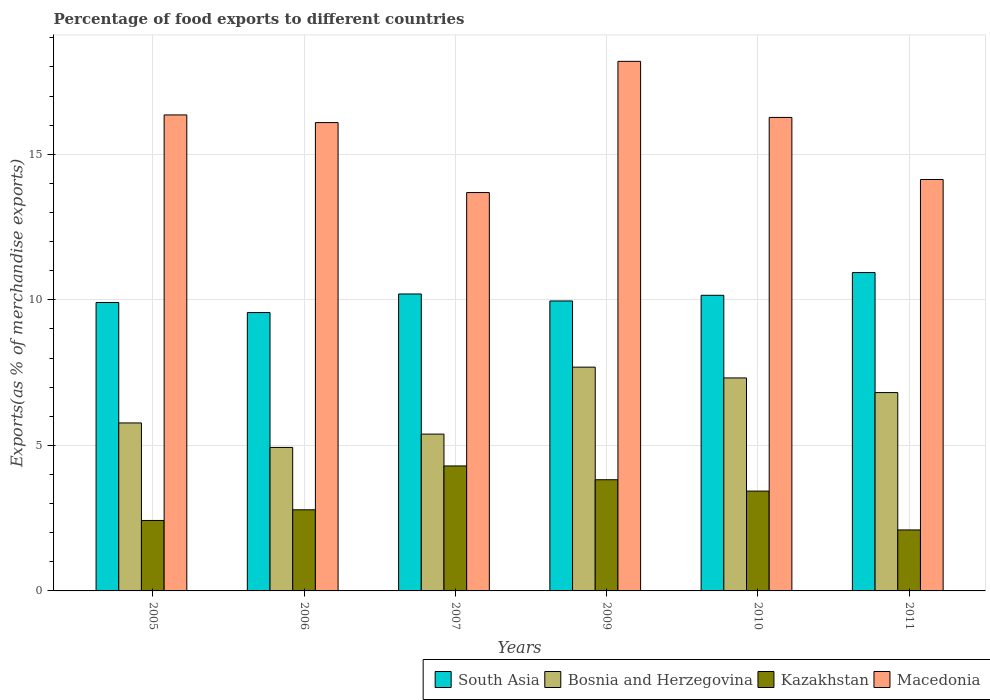How many different coloured bars are there?
Keep it short and to the point. 4. Are the number of bars on each tick of the X-axis equal?
Make the answer very short. Yes. What is the label of the 3rd group of bars from the left?
Provide a short and direct response. 2007. What is the percentage of exports to different countries in South Asia in 2009?
Your answer should be compact. 9.96. Across all years, what is the maximum percentage of exports to different countries in Kazakhstan?
Provide a succinct answer. 4.29. Across all years, what is the minimum percentage of exports to different countries in Bosnia and Herzegovina?
Offer a very short reply. 4.93. In which year was the percentage of exports to different countries in Macedonia maximum?
Your answer should be compact. 2009. In which year was the percentage of exports to different countries in Bosnia and Herzegovina minimum?
Provide a succinct answer. 2006. What is the total percentage of exports to different countries in Kazakhstan in the graph?
Provide a succinct answer. 18.85. What is the difference between the percentage of exports to different countries in South Asia in 2007 and that in 2009?
Ensure brevity in your answer.  0.24. What is the difference between the percentage of exports to different countries in South Asia in 2007 and the percentage of exports to different countries in Kazakhstan in 2011?
Make the answer very short. 8.11. What is the average percentage of exports to different countries in South Asia per year?
Your answer should be very brief. 10.12. In the year 2005, what is the difference between the percentage of exports to different countries in South Asia and percentage of exports to different countries in Bosnia and Herzegovina?
Provide a short and direct response. 4.14. In how many years, is the percentage of exports to different countries in South Asia greater than 11 %?
Give a very brief answer. 0. What is the ratio of the percentage of exports to different countries in Bosnia and Herzegovina in 2007 to that in 2011?
Ensure brevity in your answer.  0.79. Is the difference between the percentage of exports to different countries in South Asia in 2005 and 2010 greater than the difference between the percentage of exports to different countries in Bosnia and Herzegovina in 2005 and 2010?
Your answer should be compact. Yes. What is the difference between the highest and the second highest percentage of exports to different countries in Bosnia and Herzegovina?
Provide a succinct answer. 0.37. What is the difference between the highest and the lowest percentage of exports to different countries in Kazakhstan?
Offer a very short reply. 2.2. Is the sum of the percentage of exports to different countries in Kazakhstan in 2007 and 2011 greater than the maximum percentage of exports to different countries in Macedonia across all years?
Your answer should be compact. No. Is it the case that in every year, the sum of the percentage of exports to different countries in Macedonia and percentage of exports to different countries in Kazakhstan is greater than the sum of percentage of exports to different countries in South Asia and percentage of exports to different countries in Bosnia and Herzegovina?
Provide a succinct answer. Yes. What does the 3rd bar from the left in 2005 represents?
Offer a very short reply. Kazakhstan. What does the 1st bar from the right in 2006 represents?
Your answer should be compact. Macedonia. Is it the case that in every year, the sum of the percentage of exports to different countries in Kazakhstan and percentage of exports to different countries in Bosnia and Herzegovina is greater than the percentage of exports to different countries in South Asia?
Make the answer very short. No. Are all the bars in the graph horizontal?
Offer a very short reply. No. How many years are there in the graph?
Provide a short and direct response. 6. Are the values on the major ticks of Y-axis written in scientific E-notation?
Offer a very short reply. No. Does the graph contain any zero values?
Keep it short and to the point. No. Where does the legend appear in the graph?
Your response must be concise. Bottom right. What is the title of the graph?
Keep it short and to the point. Percentage of food exports to different countries. Does "Nicaragua" appear as one of the legend labels in the graph?
Provide a short and direct response. No. What is the label or title of the X-axis?
Your response must be concise. Years. What is the label or title of the Y-axis?
Offer a very short reply. Exports(as % of merchandise exports). What is the Exports(as % of merchandise exports) of South Asia in 2005?
Offer a very short reply. 9.91. What is the Exports(as % of merchandise exports) of Bosnia and Herzegovina in 2005?
Make the answer very short. 5.77. What is the Exports(as % of merchandise exports) of Kazakhstan in 2005?
Offer a very short reply. 2.42. What is the Exports(as % of merchandise exports) of Macedonia in 2005?
Ensure brevity in your answer.  16.35. What is the Exports(as % of merchandise exports) of South Asia in 2006?
Your response must be concise. 9.56. What is the Exports(as % of merchandise exports) in Bosnia and Herzegovina in 2006?
Provide a short and direct response. 4.93. What is the Exports(as % of merchandise exports) in Kazakhstan in 2006?
Provide a short and direct response. 2.79. What is the Exports(as % of merchandise exports) in Macedonia in 2006?
Provide a short and direct response. 16.09. What is the Exports(as % of merchandise exports) in South Asia in 2007?
Keep it short and to the point. 10.2. What is the Exports(as % of merchandise exports) of Bosnia and Herzegovina in 2007?
Ensure brevity in your answer.  5.39. What is the Exports(as % of merchandise exports) of Kazakhstan in 2007?
Give a very brief answer. 4.29. What is the Exports(as % of merchandise exports) of Macedonia in 2007?
Keep it short and to the point. 13.69. What is the Exports(as % of merchandise exports) in South Asia in 2009?
Your answer should be compact. 9.96. What is the Exports(as % of merchandise exports) of Bosnia and Herzegovina in 2009?
Keep it short and to the point. 7.69. What is the Exports(as % of merchandise exports) in Kazakhstan in 2009?
Offer a terse response. 3.82. What is the Exports(as % of merchandise exports) of Macedonia in 2009?
Give a very brief answer. 18.19. What is the Exports(as % of merchandise exports) in South Asia in 2010?
Offer a very short reply. 10.16. What is the Exports(as % of merchandise exports) in Bosnia and Herzegovina in 2010?
Offer a terse response. 7.32. What is the Exports(as % of merchandise exports) of Kazakhstan in 2010?
Keep it short and to the point. 3.43. What is the Exports(as % of merchandise exports) of Macedonia in 2010?
Offer a very short reply. 16.27. What is the Exports(as % of merchandise exports) of South Asia in 2011?
Ensure brevity in your answer.  10.94. What is the Exports(as % of merchandise exports) of Bosnia and Herzegovina in 2011?
Offer a terse response. 6.81. What is the Exports(as % of merchandise exports) in Kazakhstan in 2011?
Your answer should be very brief. 2.1. What is the Exports(as % of merchandise exports) of Macedonia in 2011?
Your answer should be very brief. 14.13. Across all years, what is the maximum Exports(as % of merchandise exports) in South Asia?
Provide a succinct answer. 10.94. Across all years, what is the maximum Exports(as % of merchandise exports) in Bosnia and Herzegovina?
Make the answer very short. 7.69. Across all years, what is the maximum Exports(as % of merchandise exports) in Kazakhstan?
Offer a very short reply. 4.29. Across all years, what is the maximum Exports(as % of merchandise exports) of Macedonia?
Your response must be concise. 18.19. Across all years, what is the minimum Exports(as % of merchandise exports) in South Asia?
Make the answer very short. 9.56. Across all years, what is the minimum Exports(as % of merchandise exports) in Bosnia and Herzegovina?
Offer a terse response. 4.93. Across all years, what is the minimum Exports(as % of merchandise exports) of Kazakhstan?
Offer a very short reply. 2.1. Across all years, what is the minimum Exports(as % of merchandise exports) of Macedonia?
Ensure brevity in your answer.  13.69. What is the total Exports(as % of merchandise exports) of South Asia in the graph?
Ensure brevity in your answer.  60.73. What is the total Exports(as % of merchandise exports) of Bosnia and Herzegovina in the graph?
Offer a very short reply. 37.91. What is the total Exports(as % of merchandise exports) in Kazakhstan in the graph?
Offer a terse response. 18.85. What is the total Exports(as % of merchandise exports) in Macedonia in the graph?
Your answer should be very brief. 94.72. What is the difference between the Exports(as % of merchandise exports) in South Asia in 2005 and that in 2006?
Keep it short and to the point. 0.34. What is the difference between the Exports(as % of merchandise exports) of Bosnia and Herzegovina in 2005 and that in 2006?
Your response must be concise. 0.84. What is the difference between the Exports(as % of merchandise exports) of Kazakhstan in 2005 and that in 2006?
Your answer should be very brief. -0.37. What is the difference between the Exports(as % of merchandise exports) of Macedonia in 2005 and that in 2006?
Your answer should be very brief. 0.26. What is the difference between the Exports(as % of merchandise exports) in South Asia in 2005 and that in 2007?
Keep it short and to the point. -0.29. What is the difference between the Exports(as % of merchandise exports) in Bosnia and Herzegovina in 2005 and that in 2007?
Keep it short and to the point. 0.38. What is the difference between the Exports(as % of merchandise exports) in Kazakhstan in 2005 and that in 2007?
Offer a very short reply. -1.87. What is the difference between the Exports(as % of merchandise exports) in Macedonia in 2005 and that in 2007?
Provide a short and direct response. 2.67. What is the difference between the Exports(as % of merchandise exports) in South Asia in 2005 and that in 2009?
Offer a very short reply. -0.05. What is the difference between the Exports(as % of merchandise exports) of Bosnia and Herzegovina in 2005 and that in 2009?
Make the answer very short. -1.92. What is the difference between the Exports(as % of merchandise exports) of Kazakhstan in 2005 and that in 2009?
Your answer should be very brief. -1.4. What is the difference between the Exports(as % of merchandise exports) in Macedonia in 2005 and that in 2009?
Give a very brief answer. -1.84. What is the difference between the Exports(as % of merchandise exports) of South Asia in 2005 and that in 2010?
Provide a short and direct response. -0.25. What is the difference between the Exports(as % of merchandise exports) in Bosnia and Herzegovina in 2005 and that in 2010?
Provide a short and direct response. -1.55. What is the difference between the Exports(as % of merchandise exports) of Kazakhstan in 2005 and that in 2010?
Offer a terse response. -1.01. What is the difference between the Exports(as % of merchandise exports) in Macedonia in 2005 and that in 2010?
Your answer should be compact. 0.09. What is the difference between the Exports(as % of merchandise exports) in South Asia in 2005 and that in 2011?
Keep it short and to the point. -1.03. What is the difference between the Exports(as % of merchandise exports) of Bosnia and Herzegovina in 2005 and that in 2011?
Give a very brief answer. -1.04. What is the difference between the Exports(as % of merchandise exports) in Kazakhstan in 2005 and that in 2011?
Your answer should be very brief. 0.33. What is the difference between the Exports(as % of merchandise exports) in Macedonia in 2005 and that in 2011?
Keep it short and to the point. 2.22. What is the difference between the Exports(as % of merchandise exports) of South Asia in 2006 and that in 2007?
Your answer should be compact. -0.64. What is the difference between the Exports(as % of merchandise exports) of Bosnia and Herzegovina in 2006 and that in 2007?
Make the answer very short. -0.46. What is the difference between the Exports(as % of merchandise exports) in Kazakhstan in 2006 and that in 2007?
Ensure brevity in your answer.  -1.51. What is the difference between the Exports(as % of merchandise exports) of Macedonia in 2006 and that in 2007?
Give a very brief answer. 2.4. What is the difference between the Exports(as % of merchandise exports) of South Asia in 2006 and that in 2009?
Your answer should be very brief. -0.4. What is the difference between the Exports(as % of merchandise exports) of Bosnia and Herzegovina in 2006 and that in 2009?
Provide a short and direct response. -2.76. What is the difference between the Exports(as % of merchandise exports) of Kazakhstan in 2006 and that in 2009?
Your answer should be compact. -1.03. What is the difference between the Exports(as % of merchandise exports) of Macedonia in 2006 and that in 2009?
Your answer should be compact. -2.1. What is the difference between the Exports(as % of merchandise exports) in South Asia in 2006 and that in 2010?
Provide a succinct answer. -0.59. What is the difference between the Exports(as % of merchandise exports) in Bosnia and Herzegovina in 2006 and that in 2010?
Offer a terse response. -2.39. What is the difference between the Exports(as % of merchandise exports) of Kazakhstan in 2006 and that in 2010?
Offer a terse response. -0.64. What is the difference between the Exports(as % of merchandise exports) in Macedonia in 2006 and that in 2010?
Provide a succinct answer. -0.18. What is the difference between the Exports(as % of merchandise exports) in South Asia in 2006 and that in 2011?
Provide a succinct answer. -1.37. What is the difference between the Exports(as % of merchandise exports) of Bosnia and Herzegovina in 2006 and that in 2011?
Provide a short and direct response. -1.88. What is the difference between the Exports(as % of merchandise exports) of Kazakhstan in 2006 and that in 2011?
Offer a terse response. 0.69. What is the difference between the Exports(as % of merchandise exports) in Macedonia in 2006 and that in 2011?
Ensure brevity in your answer.  1.96. What is the difference between the Exports(as % of merchandise exports) in South Asia in 2007 and that in 2009?
Provide a short and direct response. 0.24. What is the difference between the Exports(as % of merchandise exports) of Bosnia and Herzegovina in 2007 and that in 2009?
Offer a very short reply. -2.3. What is the difference between the Exports(as % of merchandise exports) in Kazakhstan in 2007 and that in 2009?
Offer a very short reply. 0.47. What is the difference between the Exports(as % of merchandise exports) in Macedonia in 2007 and that in 2009?
Give a very brief answer. -4.51. What is the difference between the Exports(as % of merchandise exports) in South Asia in 2007 and that in 2010?
Your answer should be very brief. 0.05. What is the difference between the Exports(as % of merchandise exports) of Bosnia and Herzegovina in 2007 and that in 2010?
Give a very brief answer. -1.93. What is the difference between the Exports(as % of merchandise exports) of Kazakhstan in 2007 and that in 2010?
Ensure brevity in your answer.  0.86. What is the difference between the Exports(as % of merchandise exports) of Macedonia in 2007 and that in 2010?
Give a very brief answer. -2.58. What is the difference between the Exports(as % of merchandise exports) of South Asia in 2007 and that in 2011?
Offer a very short reply. -0.74. What is the difference between the Exports(as % of merchandise exports) of Bosnia and Herzegovina in 2007 and that in 2011?
Provide a succinct answer. -1.43. What is the difference between the Exports(as % of merchandise exports) of Kazakhstan in 2007 and that in 2011?
Keep it short and to the point. 2.2. What is the difference between the Exports(as % of merchandise exports) of Macedonia in 2007 and that in 2011?
Provide a short and direct response. -0.45. What is the difference between the Exports(as % of merchandise exports) of South Asia in 2009 and that in 2010?
Make the answer very short. -0.19. What is the difference between the Exports(as % of merchandise exports) of Bosnia and Herzegovina in 2009 and that in 2010?
Give a very brief answer. 0.37. What is the difference between the Exports(as % of merchandise exports) of Kazakhstan in 2009 and that in 2010?
Make the answer very short. 0.39. What is the difference between the Exports(as % of merchandise exports) in Macedonia in 2009 and that in 2010?
Keep it short and to the point. 1.93. What is the difference between the Exports(as % of merchandise exports) in South Asia in 2009 and that in 2011?
Your response must be concise. -0.98. What is the difference between the Exports(as % of merchandise exports) of Bosnia and Herzegovina in 2009 and that in 2011?
Give a very brief answer. 0.87. What is the difference between the Exports(as % of merchandise exports) in Kazakhstan in 2009 and that in 2011?
Your response must be concise. 1.72. What is the difference between the Exports(as % of merchandise exports) of Macedonia in 2009 and that in 2011?
Provide a succinct answer. 4.06. What is the difference between the Exports(as % of merchandise exports) of South Asia in 2010 and that in 2011?
Provide a short and direct response. -0.78. What is the difference between the Exports(as % of merchandise exports) in Bosnia and Herzegovina in 2010 and that in 2011?
Your response must be concise. 0.5. What is the difference between the Exports(as % of merchandise exports) in Kazakhstan in 2010 and that in 2011?
Offer a very short reply. 1.33. What is the difference between the Exports(as % of merchandise exports) of Macedonia in 2010 and that in 2011?
Ensure brevity in your answer.  2.13. What is the difference between the Exports(as % of merchandise exports) of South Asia in 2005 and the Exports(as % of merchandise exports) of Bosnia and Herzegovina in 2006?
Keep it short and to the point. 4.98. What is the difference between the Exports(as % of merchandise exports) of South Asia in 2005 and the Exports(as % of merchandise exports) of Kazakhstan in 2006?
Keep it short and to the point. 7.12. What is the difference between the Exports(as % of merchandise exports) of South Asia in 2005 and the Exports(as % of merchandise exports) of Macedonia in 2006?
Provide a short and direct response. -6.18. What is the difference between the Exports(as % of merchandise exports) of Bosnia and Herzegovina in 2005 and the Exports(as % of merchandise exports) of Kazakhstan in 2006?
Keep it short and to the point. 2.98. What is the difference between the Exports(as % of merchandise exports) in Bosnia and Herzegovina in 2005 and the Exports(as % of merchandise exports) in Macedonia in 2006?
Your answer should be compact. -10.32. What is the difference between the Exports(as % of merchandise exports) in Kazakhstan in 2005 and the Exports(as % of merchandise exports) in Macedonia in 2006?
Offer a terse response. -13.67. What is the difference between the Exports(as % of merchandise exports) in South Asia in 2005 and the Exports(as % of merchandise exports) in Bosnia and Herzegovina in 2007?
Offer a very short reply. 4.52. What is the difference between the Exports(as % of merchandise exports) of South Asia in 2005 and the Exports(as % of merchandise exports) of Kazakhstan in 2007?
Your response must be concise. 5.61. What is the difference between the Exports(as % of merchandise exports) in South Asia in 2005 and the Exports(as % of merchandise exports) in Macedonia in 2007?
Offer a terse response. -3.78. What is the difference between the Exports(as % of merchandise exports) of Bosnia and Herzegovina in 2005 and the Exports(as % of merchandise exports) of Kazakhstan in 2007?
Your answer should be compact. 1.48. What is the difference between the Exports(as % of merchandise exports) of Bosnia and Herzegovina in 2005 and the Exports(as % of merchandise exports) of Macedonia in 2007?
Provide a short and direct response. -7.92. What is the difference between the Exports(as % of merchandise exports) in Kazakhstan in 2005 and the Exports(as % of merchandise exports) in Macedonia in 2007?
Give a very brief answer. -11.27. What is the difference between the Exports(as % of merchandise exports) of South Asia in 2005 and the Exports(as % of merchandise exports) of Bosnia and Herzegovina in 2009?
Your answer should be compact. 2.22. What is the difference between the Exports(as % of merchandise exports) in South Asia in 2005 and the Exports(as % of merchandise exports) in Kazakhstan in 2009?
Offer a terse response. 6.09. What is the difference between the Exports(as % of merchandise exports) of South Asia in 2005 and the Exports(as % of merchandise exports) of Macedonia in 2009?
Your response must be concise. -8.28. What is the difference between the Exports(as % of merchandise exports) in Bosnia and Herzegovina in 2005 and the Exports(as % of merchandise exports) in Kazakhstan in 2009?
Ensure brevity in your answer.  1.95. What is the difference between the Exports(as % of merchandise exports) of Bosnia and Herzegovina in 2005 and the Exports(as % of merchandise exports) of Macedonia in 2009?
Your answer should be compact. -12.42. What is the difference between the Exports(as % of merchandise exports) in Kazakhstan in 2005 and the Exports(as % of merchandise exports) in Macedonia in 2009?
Your answer should be compact. -15.77. What is the difference between the Exports(as % of merchandise exports) of South Asia in 2005 and the Exports(as % of merchandise exports) of Bosnia and Herzegovina in 2010?
Your answer should be compact. 2.59. What is the difference between the Exports(as % of merchandise exports) in South Asia in 2005 and the Exports(as % of merchandise exports) in Kazakhstan in 2010?
Provide a short and direct response. 6.48. What is the difference between the Exports(as % of merchandise exports) in South Asia in 2005 and the Exports(as % of merchandise exports) in Macedonia in 2010?
Your answer should be very brief. -6.36. What is the difference between the Exports(as % of merchandise exports) in Bosnia and Herzegovina in 2005 and the Exports(as % of merchandise exports) in Kazakhstan in 2010?
Give a very brief answer. 2.34. What is the difference between the Exports(as % of merchandise exports) of Bosnia and Herzegovina in 2005 and the Exports(as % of merchandise exports) of Macedonia in 2010?
Ensure brevity in your answer.  -10.5. What is the difference between the Exports(as % of merchandise exports) of Kazakhstan in 2005 and the Exports(as % of merchandise exports) of Macedonia in 2010?
Provide a succinct answer. -13.85. What is the difference between the Exports(as % of merchandise exports) in South Asia in 2005 and the Exports(as % of merchandise exports) in Bosnia and Herzegovina in 2011?
Provide a short and direct response. 3.09. What is the difference between the Exports(as % of merchandise exports) of South Asia in 2005 and the Exports(as % of merchandise exports) of Kazakhstan in 2011?
Your response must be concise. 7.81. What is the difference between the Exports(as % of merchandise exports) of South Asia in 2005 and the Exports(as % of merchandise exports) of Macedonia in 2011?
Your answer should be very brief. -4.23. What is the difference between the Exports(as % of merchandise exports) in Bosnia and Herzegovina in 2005 and the Exports(as % of merchandise exports) in Kazakhstan in 2011?
Give a very brief answer. 3.68. What is the difference between the Exports(as % of merchandise exports) in Bosnia and Herzegovina in 2005 and the Exports(as % of merchandise exports) in Macedonia in 2011?
Offer a terse response. -8.36. What is the difference between the Exports(as % of merchandise exports) in Kazakhstan in 2005 and the Exports(as % of merchandise exports) in Macedonia in 2011?
Make the answer very short. -11.71. What is the difference between the Exports(as % of merchandise exports) in South Asia in 2006 and the Exports(as % of merchandise exports) in Bosnia and Herzegovina in 2007?
Your response must be concise. 4.18. What is the difference between the Exports(as % of merchandise exports) in South Asia in 2006 and the Exports(as % of merchandise exports) in Kazakhstan in 2007?
Provide a succinct answer. 5.27. What is the difference between the Exports(as % of merchandise exports) of South Asia in 2006 and the Exports(as % of merchandise exports) of Macedonia in 2007?
Your response must be concise. -4.12. What is the difference between the Exports(as % of merchandise exports) in Bosnia and Herzegovina in 2006 and the Exports(as % of merchandise exports) in Kazakhstan in 2007?
Provide a short and direct response. 0.64. What is the difference between the Exports(as % of merchandise exports) in Bosnia and Herzegovina in 2006 and the Exports(as % of merchandise exports) in Macedonia in 2007?
Your answer should be compact. -8.76. What is the difference between the Exports(as % of merchandise exports) in Kazakhstan in 2006 and the Exports(as % of merchandise exports) in Macedonia in 2007?
Ensure brevity in your answer.  -10.9. What is the difference between the Exports(as % of merchandise exports) in South Asia in 2006 and the Exports(as % of merchandise exports) in Bosnia and Herzegovina in 2009?
Provide a succinct answer. 1.88. What is the difference between the Exports(as % of merchandise exports) of South Asia in 2006 and the Exports(as % of merchandise exports) of Kazakhstan in 2009?
Provide a succinct answer. 5.74. What is the difference between the Exports(as % of merchandise exports) of South Asia in 2006 and the Exports(as % of merchandise exports) of Macedonia in 2009?
Your answer should be compact. -8.63. What is the difference between the Exports(as % of merchandise exports) in Bosnia and Herzegovina in 2006 and the Exports(as % of merchandise exports) in Kazakhstan in 2009?
Offer a terse response. 1.11. What is the difference between the Exports(as % of merchandise exports) in Bosnia and Herzegovina in 2006 and the Exports(as % of merchandise exports) in Macedonia in 2009?
Keep it short and to the point. -13.26. What is the difference between the Exports(as % of merchandise exports) of Kazakhstan in 2006 and the Exports(as % of merchandise exports) of Macedonia in 2009?
Provide a short and direct response. -15.41. What is the difference between the Exports(as % of merchandise exports) in South Asia in 2006 and the Exports(as % of merchandise exports) in Bosnia and Herzegovina in 2010?
Provide a short and direct response. 2.25. What is the difference between the Exports(as % of merchandise exports) of South Asia in 2006 and the Exports(as % of merchandise exports) of Kazakhstan in 2010?
Give a very brief answer. 6.13. What is the difference between the Exports(as % of merchandise exports) in South Asia in 2006 and the Exports(as % of merchandise exports) in Macedonia in 2010?
Provide a short and direct response. -6.7. What is the difference between the Exports(as % of merchandise exports) in Bosnia and Herzegovina in 2006 and the Exports(as % of merchandise exports) in Kazakhstan in 2010?
Give a very brief answer. 1.5. What is the difference between the Exports(as % of merchandise exports) of Bosnia and Herzegovina in 2006 and the Exports(as % of merchandise exports) of Macedonia in 2010?
Give a very brief answer. -11.34. What is the difference between the Exports(as % of merchandise exports) of Kazakhstan in 2006 and the Exports(as % of merchandise exports) of Macedonia in 2010?
Provide a short and direct response. -13.48. What is the difference between the Exports(as % of merchandise exports) of South Asia in 2006 and the Exports(as % of merchandise exports) of Bosnia and Herzegovina in 2011?
Offer a very short reply. 2.75. What is the difference between the Exports(as % of merchandise exports) in South Asia in 2006 and the Exports(as % of merchandise exports) in Kazakhstan in 2011?
Provide a short and direct response. 7.47. What is the difference between the Exports(as % of merchandise exports) of South Asia in 2006 and the Exports(as % of merchandise exports) of Macedonia in 2011?
Give a very brief answer. -4.57. What is the difference between the Exports(as % of merchandise exports) in Bosnia and Herzegovina in 2006 and the Exports(as % of merchandise exports) in Kazakhstan in 2011?
Your response must be concise. 2.83. What is the difference between the Exports(as % of merchandise exports) of Bosnia and Herzegovina in 2006 and the Exports(as % of merchandise exports) of Macedonia in 2011?
Provide a succinct answer. -9.2. What is the difference between the Exports(as % of merchandise exports) of Kazakhstan in 2006 and the Exports(as % of merchandise exports) of Macedonia in 2011?
Offer a very short reply. -11.35. What is the difference between the Exports(as % of merchandise exports) in South Asia in 2007 and the Exports(as % of merchandise exports) in Bosnia and Herzegovina in 2009?
Your answer should be very brief. 2.51. What is the difference between the Exports(as % of merchandise exports) of South Asia in 2007 and the Exports(as % of merchandise exports) of Kazakhstan in 2009?
Give a very brief answer. 6.38. What is the difference between the Exports(as % of merchandise exports) of South Asia in 2007 and the Exports(as % of merchandise exports) of Macedonia in 2009?
Your answer should be compact. -7.99. What is the difference between the Exports(as % of merchandise exports) in Bosnia and Herzegovina in 2007 and the Exports(as % of merchandise exports) in Kazakhstan in 2009?
Your response must be concise. 1.57. What is the difference between the Exports(as % of merchandise exports) in Bosnia and Herzegovina in 2007 and the Exports(as % of merchandise exports) in Macedonia in 2009?
Provide a succinct answer. -12.81. What is the difference between the Exports(as % of merchandise exports) in Kazakhstan in 2007 and the Exports(as % of merchandise exports) in Macedonia in 2009?
Your answer should be compact. -13.9. What is the difference between the Exports(as % of merchandise exports) in South Asia in 2007 and the Exports(as % of merchandise exports) in Bosnia and Herzegovina in 2010?
Your response must be concise. 2.88. What is the difference between the Exports(as % of merchandise exports) in South Asia in 2007 and the Exports(as % of merchandise exports) in Kazakhstan in 2010?
Give a very brief answer. 6.77. What is the difference between the Exports(as % of merchandise exports) in South Asia in 2007 and the Exports(as % of merchandise exports) in Macedonia in 2010?
Provide a short and direct response. -6.07. What is the difference between the Exports(as % of merchandise exports) of Bosnia and Herzegovina in 2007 and the Exports(as % of merchandise exports) of Kazakhstan in 2010?
Keep it short and to the point. 1.96. What is the difference between the Exports(as % of merchandise exports) of Bosnia and Herzegovina in 2007 and the Exports(as % of merchandise exports) of Macedonia in 2010?
Ensure brevity in your answer.  -10.88. What is the difference between the Exports(as % of merchandise exports) of Kazakhstan in 2007 and the Exports(as % of merchandise exports) of Macedonia in 2010?
Offer a very short reply. -11.97. What is the difference between the Exports(as % of merchandise exports) in South Asia in 2007 and the Exports(as % of merchandise exports) in Bosnia and Herzegovina in 2011?
Provide a succinct answer. 3.39. What is the difference between the Exports(as % of merchandise exports) of South Asia in 2007 and the Exports(as % of merchandise exports) of Kazakhstan in 2011?
Provide a short and direct response. 8.11. What is the difference between the Exports(as % of merchandise exports) in South Asia in 2007 and the Exports(as % of merchandise exports) in Macedonia in 2011?
Provide a short and direct response. -3.93. What is the difference between the Exports(as % of merchandise exports) in Bosnia and Herzegovina in 2007 and the Exports(as % of merchandise exports) in Kazakhstan in 2011?
Provide a short and direct response. 3.29. What is the difference between the Exports(as % of merchandise exports) of Bosnia and Herzegovina in 2007 and the Exports(as % of merchandise exports) of Macedonia in 2011?
Your answer should be compact. -8.75. What is the difference between the Exports(as % of merchandise exports) of Kazakhstan in 2007 and the Exports(as % of merchandise exports) of Macedonia in 2011?
Offer a very short reply. -9.84. What is the difference between the Exports(as % of merchandise exports) of South Asia in 2009 and the Exports(as % of merchandise exports) of Bosnia and Herzegovina in 2010?
Your response must be concise. 2.64. What is the difference between the Exports(as % of merchandise exports) of South Asia in 2009 and the Exports(as % of merchandise exports) of Kazakhstan in 2010?
Offer a very short reply. 6.53. What is the difference between the Exports(as % of merchandise exports) of South Asia in 2009 and the Exports(as % of merchandise exports) of Macedonia in 2010?
Offer a terse response. -6.31. What is the difference between the Exports(as % of merchandise exports) of Bosnia and Herzegovina in 2009 and the Exports(as % of merchandise exports) of Kazakhstan in 2010?
Provide a short and direct response. 4.26. What is the difference between the Exports(as % of merchandise exports) of Bosnia and Herzegovina in 2009 and the Exports(as % of merchandise exports) of Macedonia in 2010?
Provide a short and direct response. -8.58. What is the difference between the Exports(as % of merchandise exports) of Kazakhstan in 2009 and the Exports(as % of merchandise exports) of Macedonia in 2010?
Give a very brief answer. -12.45. What is the difference between the Exports(as % of merchandise exports) in South Asia in 2009 and the Exports(as % of merchandise exports) in Bosnia and Herzegovina in 2011?
Offer a terse response. 3.15. What is the difference between the Exports(as % of merchandise exports) of South Asia in 2009 and the Exports(as % of merchandise exports) of Kazakhstan in 2011?
Offer a terse response. 7.87. What is the difference between the Exports(as % of merchandise exports) of South Asia in 2009 and the Exports(as % of merchandise exports) of Macedonia in 2011?
Offer a very short reply. -4.17. What is the difference between the Exports(as % of merchandise exports) of Bosnia and Herzegovina in 2009 and the Exports(as % of merchandise exports) of Kazakhstan in 2011?
Ensure brevity in your answer.  5.59. What is the difference between the Exports(as % of merchandise exports) in Bosnia and Herzegovina in 2009 and the Exports(as % of merchandise exports) in Macedonia in 2011?
Ensure brevity in your answer.  -6.45. What is the difference between the Exports(as % of merchandise exports) in Kazakhstan in 2009 and the Exports(as % of merchandise exports) in Macedonia in 2011?
Your response must be concise. -10.31. What is the difference between the Exports(as % of merchandise exports) of South Asia in 2010 and the Exports(as % of merchandise exports) of Bosnia and Herzegovina in 2011?
Make the answer very short. 3.34. What is the difference between the Exports(as % of merchandise exports) of South Asia in 2010 and the Exports(as % of merchandise exports) of Kazakhstan in 2011?
Offer a very short reply. 8.06. What is the difference between the Exports(as % of merchandise exports) of South Asia in 2010 and the Exports(as % of merchandise exports) of Macedonia in 2011?
Provide a short and direct response. -3.98. What is the difference between the Exports(as % of merchandise exports) of Bosnia and Herzegovina in 2010 and the Exports(as % of merchandise exports) of Kazakhstan in 2011?
Give a very brief answer. 5.22. What is the difference between the Exports(as % of merchandise exports) in Bosnia and Herzegovina in 2010 and the Exports(as % of merchandise exports) in Macedonia in 2011?
Keep it short and to the point. -6.82. What is the difference between the Exports(as % of merchandise exports) of Kazakhstan in 2010 and the Exports(as % of merchandise exports) of Macedonia in 2011?
Give a very brief answer. -10.7. What is the average Exports(as % of merchandise exports) of South Asia per year?
Your answer should be very brief. 10.12. What is the average Exports(as % of merchandise exports) of Bosnia and Herzegovina per year?
Your response must be concise. 6.32. What is the average Exports(as % of merchandise exports) in Kazakhstan per year?
Offer a very short reply. 3.14. What is the average Exports(as % of merchandise exports) of Macedonia per year?
Make the answer very short. 15.79. In the year 2005, what is the difference between the Exports(as % of merchandise exports) in South Asia and Exports(as % of merchandise exports) in Bosnia and Herzegovina?
Your answer should be very brief. 4.14. In the year 2005, what is the difference between the Exports(as % of merchandise exports) in South Asia and Exports(as % of merchandise exports) in Kazakhstan?
Keep it short and to the point. 7.49. In the year 2005, what is the difference between the Exports(as % of merchandise exports) of South Asia and Exports(as % of merchandise exports) of Macedonia?
Make the answer very short. -6.44. In the year 2005, what is the difference between the Exports(as % of merchandise exports) of Bosnia and Herzegovina and Exports(as % of merchandise exports) of Kazakhstan?
Make the answer very short. 3.35. In the year 2005, what is the difference between the Exports(as % of merchandise exports) of Bosnia and Herzegovina and Exports(as % of merchandise exports) of Macedonia?
Ensure brevity in your answer.  -10.58. In the year 2005, what is the difference between the Exports(as % of merchandise exports) of Kazakhstan and Exports(as % of merchandise exports) of Macedonia?
Ensure brevity in your answer.  -13.93. In the year 2006, what is the difference between the Exports(as % of merchandise exports) in South Asia and Exports(as % of merchandise exports) in Bosnia and Herzegovina?
Your response must be concise. 4.63. In the year 2006, what is the difference between the Exports(as % of merchandise exports) in South Asia and Exports(as % of merchandise exports) in Kazakhstan?
Offer a terse response. 6.78. In the year 2006, what is the difference between the Exports(as % of merchandise exports) in South Asia and Exports(as % of merchandise exports) in Macedonia?
Ensure brevity in your answer.  -6.53. In the year 2006, what is the difference between the Exports(as % of merchandise exports) of Bosnia and Herzegovina and Exports(as % of merchandise exports) of Kazakhstan?
Make the answer very short. 2.14. In the year 2006, what is the difference between the Exports(as % of merchandise exports) in Bosnia and Herzegovina and Exports(as % of merchandise exports) in Macedonia?
Provide a short and direct response. -11.16. In the year 2006, what is the difference between the Exports(as % of merchandise exports) of Kazakhstan and Exports(as % of merchandise exports) of Macedonia?
Your answer should be very brief. -13.3. In the year 2007, what is the difference between the Exports(as % of merchandise exports) in South Asia and Exports(as % of merchandise exports) in Bosnia and Herzegovina?
Provide a succinct answer. 4.81. In the year 2007, what is the difference between the Exports(as % of merchandise exports) in South Asia and Exports(as % of merchandise exports) in Kazakhstan?
Keep it short and to the point. 5.91. In the year 2007, what is the difference between the Exports(as % of merchandise exports) in South Asia and Exports(as % of merchandise exports) in Macedonia?
Keep it short and to the point. -3.48. In the year 2007, what is the difference between the Exports(as % of merchandise exports) of Bosnia and Herzegovina and Exports(as % of merchandise exports) of Kazakhstan?
Offer a very short reply. 1.09. In the year 2007, what is the difference between the Exports(as % of merchandise exports) in Bosnia and Herzegovina and Exports(as % of merchandise exports) in Macedonia?
Your answer should be very brief. -8.3. In the year 2007, what is the difference between the Exports(as % of merchandise exports) in Kazakhstan and Exports(as % of merchandise exports) in Macedonia?
Keep it short and to the point. -9.39. In the year 2009, what is the difference between the Exports(as % of merchandise exports) in South Asia and Exports(as % of merchandise exports) in Bosnia and Herzegovina?
Provide a short and direct response. 2.27. In the year 2009, what is the difference between the Exports(as % of merchandise exports) in South Asia and Exports(as % of merchandise exports) in Kazakhstan?
Give a very brief answer. 6.14. In the year 2009, what is the difference between the Exports(as % of merchandise exports) of South Asia and Exports(as % of merchandise exports) of Macedonia?
Offer a terse response. -8.23. In the year 2009, what is the difference between the Exports(as % of merchandise exports) of Bosnia and Herzegovina and Exports(as % of merchandise exports) of Kazakhstan?
Provide a succinct answer. 3.87. In the year 2009, what is the difference between the Exports(as % of merchandise exports) in Bosnia and Herzegovina and Exports(as % of merchandise exports) in Macedonia?
Provide a short and direct response. -10.51. In the year 2009, what is the difference between the Exports(as % of merchandise exports) of Kazakhstan and Exports(as % of merchandise exports) of Macedonia?
Your answer should be very brief. -14.37. In the year 2010, what is the difference between the Exports(as % of merchandise exports) of South Asia and Exports(as % of merchandise exports) of Bosnia and Herzegovina?
Offer a very short reply. 2.84. In the year 2010, what is the difference between the Exports(as % of merchandise exports) of South Asia and Exports(as % of merchandise exports) of Kazakhstan?
Provide a succinct answer. 6.73. In the year 2010, what is the difference between the Exports(as % of merchandise exports) of South Asia and Exports(as % of merchandise exports) of Macedonia?
Ensure brevity in your answer.  -6.11. In the year 2010, what is the difference between the Exports(as % of merchandise exports) in Bosnia and Herzegovina and Exports(as % of merchandise exports) in Kazakhstan?
Offer a very short reply. 3.89. In the year 2010, what is the difference between the Exports(as % of merchandise exports) of Bosnia and Herzegovina and Exports(as % of merchandise exports) of Macedonia?
Offer a very short reply. -8.95. In the year 2010, what is the difference between the Exports(as % of merchandise exports) of Kazakhstan and Exports(as % of merchandise exports) of Macedonia?
Give a very brief answer. -12.84. In the year 2011, what is the difference between the Exports(as % of merchandise exports) in South Asia and Exports(as % of merchandise exports) in Bosnia and Herzegovina?
Offer a terse response. 4.12. In the year 2011, what is the difference between the Exports(as % of merchandise exports) of South Asia and Exports(as % of merchandise exports) of Kazakhstan?
Your answer should be very brief. 8.84. In the year 2011, what is the difference between the Exports(as % of merchandise exports) in South Asia and Exports(as % of merchandise exports) in Macedonia?
Offer a terse response. -3.2. In the year 2011, what is the difference between the Exports(as % of merchandise exports) in Bosnia and Herzegovina and Exports(as % of merchandise exports) in Kazakhstan?
Give a very brief answer. 4.72. In the year 2011, what is the difference between the Exports(as % of merchandise exports) in Bosnia and Herzegovina and Exports(as % of merchandise exports) in Macedonia?
Provide a succinct answer. -7.32. In the year 2011, what is the difference between the Exports(as % of merchandise exports) in Kazakhstan and Exports(as % of merchandise exports) in Macedonia?
Give a very brief answer. -12.04. What is the ratio of the Exports(as % of merchandise exports) in South Asia in 2005 to that in 2006?
Your answer should be very brief. 1.04. What is the ratio of the Exports(as % of merchandise exports) of Bosnia and Herzegovina in 2005 to that in 2006?
Make the answer very short. 1.17. What is the ratio of the Exports(as % of merchandise exports) of Kazakhstan in 2005 to that in 2006?
Give a very brief answer. 0.87. What is the ratio of the Exports(as % of merchandise exports) in Macedonia in 2005 to that in 2006?
Ensure brevity in your answer.  1.02. What is the ratio of the Exports(as % of merchandise exports) of South Asia in 2005 to that in 2007?
Your answer should be compact. 0.97. What is the ratio of the Exports(as % of merchandise exports) of Bosnia and Herzegovina in 2005 to that in 2007?
Offer a very short reply. 1.07. What is the ratio of the Exports(as % of merchandise exports) in Kazakhstan in 2005 to that in 2007?
Offer a very short reply. 0.56. What is the ratio of the Exports(as % of merchandise exports) of Macedonia in 2005 to that in 2007?
Provide a succinct answer. 1.19. What is the ratio of the Exports(as % of merchandise exports) of Bosnia and Herzegovina in 2005 to that in 2009?
Ensure brevity in your answer.  0.75. What is the ratio of the Exports(as % of merchandise exports) of Kazakhstan in 2005 to that in 2009?
Provide a succinct answer. 0.63. What is the ratio of the Exports(as % of merchandise exports) in Macedonia in 2005 to that in 2009?
Make the answer very short. 0.9. What is the ratio of the Exports(as % of merchandise exports) in South Asia in 2005 to that in 2010?
Provide a succinct answer. 0.98. What is the ratio of the Exports(as % of merchandise exports) in Bosnia and Herzegovina in 2005 to that in 2010?
Offer a terse response. 0.79. What is the ratio of the Exports(as % of merchandise exports) of Kazakhstan in 2005 to that in 2010?
Offer a very short reply. 0.71. What is the ratio of the Exports(as % of merchandise exports) in South Asia in 2005 to that in 2011?
Your response must be concise. 0.91. What is the ratio of the Exports(as % of merchandise exports) of Bosnia and Herzegovina in 2005 to that in 2011?
Keep it short and to the point. 0.85. What is the ratio of the Exports(as % of merchandise exports) of Kazakhstan in 2005 to that in 2011?
Provide a succinct answer. 1.16. What is the ratio of the Exports(as % of merchandise exports) of Macedonia in 2005 to that in 2011?
Ensure brevity in your answer.  1.16. What is the ratio of the Exports(as % of merchandise exports) in Bosnia and Herzegovina in 2006 to that in 2007?
Keep it short and to the point. 0.92. What is the ratio of the Exports(as % of merchandise exports) in Kazakhstan in 2006 to that in 2007?
Your answer should be compact. 0.65. What is the ratio of the Exports(as % of merchandise exports) of Macedonia in 2006 to that in 2007?
Make the answer very short. 1.18. What is the ratio of the Exports(as % of merchandise exports) of South Asia in 2006 to that in 2009?
Give a very brief answer. 0.96. What is the ratio of the Exports(as % of merchandise exports) in Bosnia and Herzegovina in 2006 to that in 2009?
Your response must be concise. 0.64. What is the ratio of the Exports(as % of merchandise exports) in Kazakhstan in 2006 to that in 2009?
Provide a succinct answer. 0.73. What is the ratio of the Exports(as % of merchandise exports) in Macedonia in 2006 to that in 2009?
Give a very brief answer. 0.88. What is the ratio of the Exports(as % of merchandise exports) in South Asia in 2006 to that in 2010?
Give a very brief answer. 0.94. What is the ratio of the Exports(as % of merchandise exports) of Bosnia and Herzegovina in 2006 to that in 2010?
Make the answer very short. 0.67. What is the ratio of the Exports(as % of merchandise exports) in Kazakhstan in 2006 to that in 2010?
Keep it short and to the point. 0.81. What is the ratio of the Exports(as % of merchandise exports) in South Asia in 2006 to that in 2011?
Keep it short and to the point. 0.87. What is the ratio of the Exports(as % of merchandise exports) of Bosnia and Herzegovina in 2006 to that in 2011?
Offer a terse response. 0.72. What is the ratio of the Exports(as % of merchandise exports) of Kazakhstan in 2006 to that in 2011?
Provide a succinct answer. 1.33. What is the ratio of the Exports(as % of merchandise exports) in Macedonia in 2006 to that in 2011?
Your response must be concise. 1.14. What is the ratio of the Exports(as % of merchandise exports) of South Asia in 2007 to that in 2009?
Your response must be concise. 1.02. What is the ratio of the Exports(as % of merchandise exports) of Bosnia and Herzegovina in 2007 to that in 2009?
Provide a succinct answer. 0.7. What is the ratio of the Exports(as % of merchandise exports) of Kazakhstan in 2007 to that in 2009?
Ensure brevity in your answer.  1.12. What is the ratio of the Exports(as % of merchandise exports) in Macedonia in 2007 to that in 2009?
Give a very brief answer. 0.75. What is the ratio of the Exports(as % of merchandise exports) in South Asia in 2007 to that in 2010?
Your response must be concise. 1. What is the ratio of the Exports(as % of merchandise exports) in Bosnia and Herzegovina in 2007 to that in 2010?
Provide a short and direct response. 0.74. What is the ratio of the Exports(as % of merchandise exports) of Kazakhstan in 2007 to that in 2010?
Your answer should be very brief. 1.25. What is the ratio of the Exports(as % of merchandise exports) of Macedonia in 2007 to that in 2010?
Offer a very short reply. 0.84. What is the ratio of the Exports(as % of merchandise exports) of South Asia in 2007 to that in 2011?
Your answer should be very brief. 0.93. What is the ratio of the Exports(as % of merchandise exports) in Bosnia and Herzegovina in 2007 to that in 2011?
Offer a very short reply. 0.79. What is the ratio of the Exports(as % of merchandise exports) in Kazakhstan in 2007 to that in 2011?
Provide a succinct answer. 2.05. What is the ratio of the Exports(as % of merchandise exports) in Macedonia in 2007 to that in 2011?
Ensure brevity in your answer.  0.97. What is the ratio of the Exports(as % of merchandise exports) of South Asia in 2009 to that in 2010?
Make the answer very short. 0.98. What is the ratio of the Exports(as % of merchandise exports) in Bosnia and Herzegovina in 2009 to that in 2010?
Offer a very short reply. 1.05. What is the ratio of the Exports(as % of merchandise exports) of Kazakhstan in 2009 to that in 2010?
Keep it short and to the point. 1.11. What is the ratio of the Exports(as % of merchandise exports) in Macedonia in 2009 to that in 2010?
Your answer should be compact. 1.12. What is the ratio of the Exports(as % of merchandise exports) in South Asia in 2009 to that in 2011?
Make the answer very short. 0.91. What is the ratio of the Exports(as % of merchandise exports) in Bosnia and Herzegovina in 2009 to that in 2011?
Your response must be concise. 1.13. What is the ratio of the Exports(as % of merchandise exports) of Kazakhstan in 2009 to that in 2011?
Offer a very short reply. 1.82. What is the ratio of the Exports(as % of merchandise exports) of Macedonia in 2009 to that in 2011?
Offer a very short reply. 1.29. What is the ratio of the Exports(as % of merchandise exports) of South Asia in 2010 to that in 2011?
Your answer should be very brief. 0.93. What is the ratio of the Exports(as % of merchandise exports) in Bosnia and Herzegovina in 2010 to that in 2011?
Give a very brief answer. 1.07. What is the ratio of the Exports(as % of merchandise exports) of Kazakhstan in 2010 to that in 2011?
Give a very brief answer. 1.64. What is the ratio of the Exports(as % of merchandise exports) of Macedonia in 2010 to that in 2011?
Make the answer very short. 1.15. What is the difference between the highest and the second highest Exports(as % of merchandise exports) in South Asia?
Offer a terse response. 0.74. What is the difference between the highest and the second highest Exports(as % of merchandise exports) in Bosnia and Herzegovina?
Make the answer very short. 0.37. What is the difference between the highest and the second highest Exports(as % of merchandise exports) in Kazakhstan?
Offer a very short reply. 0.47. What is the difference between the highest and the second highest Exports(as % of merchandise exports) of Macedonia?
Provide a succinct answer. 1.84. What is the difference between the highest and the lowest Exports(as % of merchandise exports) of South Asia?
Provide a succinct answer. 1.37. What is the difference between the highest and the lowest Exports(as % of merchandise exports) in Bosnia and Herzegovina?
Give a very brief answer. 2.76. What is the difference between the highest and the lowest Exports(as % of merchandise exports) in Kazakhstan?
Keep it short and to the point. 2.2. What is the difference between the highest and the lowest Exports(as % of merchandise exports) of Macedonia?
Ensure brevity in your answer.  4.51. 